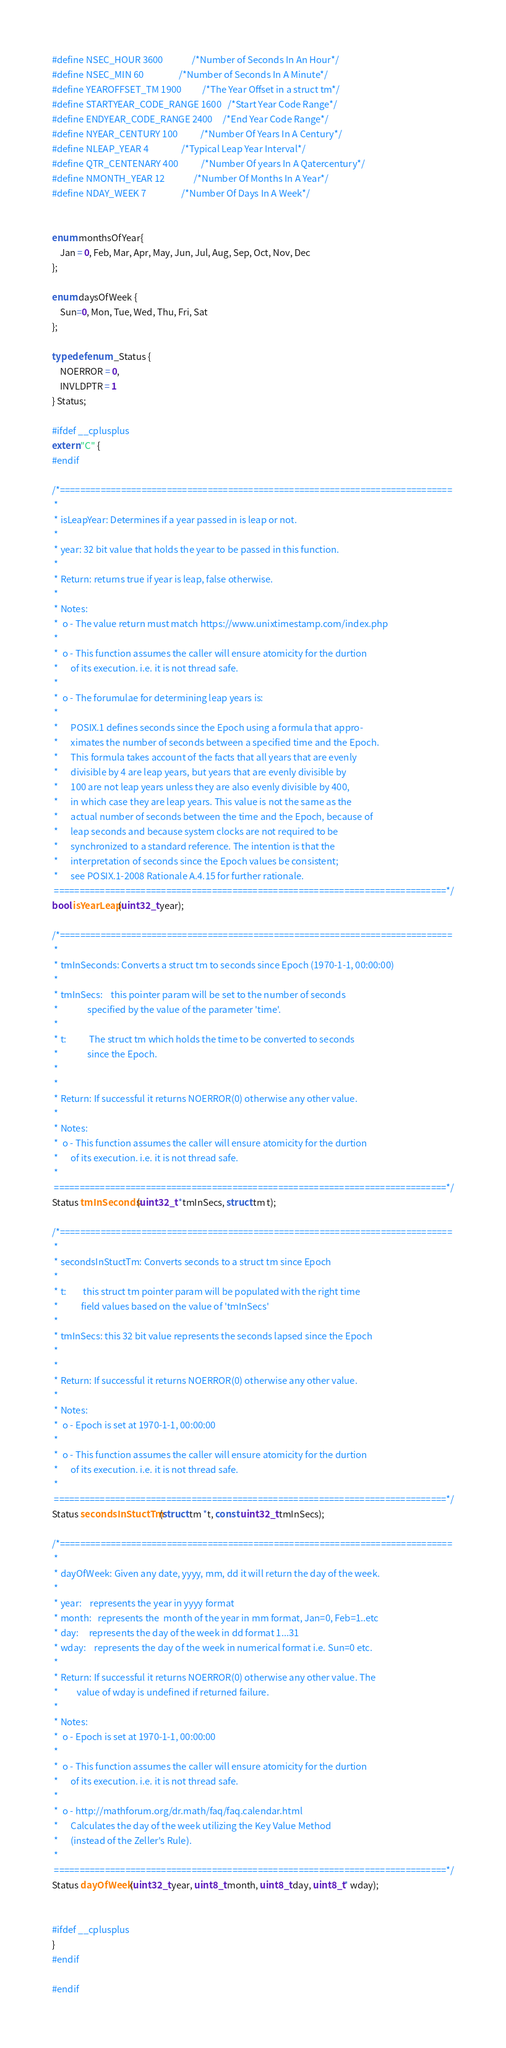<code> <loc_0><loc_0><loc_500><loc_500><_C_>#define NSEC_HOUR 3600              /*Number of Seconds In An Hour*/
#define NSEC_MIN 60                 /*Number of Seconds In A Minute*/
#define YEAROFFSET_TM 1900          /*The Year Offset in a struct tm*/
#define STARTYEAR_CODE_RANGE 1600   /*Start Year Code Range*/
#define ENDYEAR_CODE_RANGE 2400     /*End Year Code Range*/
#define NYEAR_CENTURY 100           /*Number Of Years In A Century*/
#define NLEAP_YEAR 4                /*Typical Leap Year Interval*/
#define QTR_CENTENARY 400           /*Number Of years In A Qatercentury*/
#define NMONTH_YEAR 12              /*Number Of Months In A Year*/
#define NDAY_WEEK 7                 /*Number Of Days In A Week*/


enum monthsOfYear{
    Jan = 0, Feb, Mar, Apr, May, Jun, Jul, Aug, Sep, Oct, Nov, Dec
};

enum daysOfWeek {
    Sun=0, Mon, Tue, Wed, Thu, Fri, Sat
};

typedef enum _Status {
    NOERROR = 0,
    INVLDPTR = 1
} Status;

#ifdef __cplusplus
extern "C" {
#endif

/*=============================================================================
 *
 * isLeapYear: Determines if a year passed in is leap or not.
 *
 * year: 32 bit value that holds the year to be passed in this function.
 *
 * Return: returns true if year is leap, false otherwise.
 *
 * Notes:
 *  o - The value return must match https://www.unixtimestamp.com/index.php
 *
 *  o - This function assumes the caller will ensure atomicity for the durtion
 *      of its execution. i.e. it is not thread safe.
 *
 *  o - The forumulae for determining leap years is:
 *
 *      POSIX.1 defines seconds since the Epoch using a formula that appro-
 *      ximates the number of seconds between a specified time and the Epoch.
 *      This formula takes account of the facts that all years that are evenly
 *      divisible by 4 are leap years, but years that are evenly divisible by
 *      100 are not leap years unless they are also evenly divisible by 400,
 *      in which case they are leap years. This value is not the same as the
 *      actual number of seconds between the time and the Epoch, because of
 *      leap seconds and because system clocks are not required to be
 *      synchronized to a standard reference. The intention is that the
 *      interpretation of seconds since the Epoch values be consistent;
 *      see POSIX.1-2008 Rationale A.4.15 for further rationale.
 =============================================================================*/
bool isYearLeap(uint32_t year);

/*=============================================================================
 *
 * tmInSeconds: Converts a struct tm to seconds since Epoch (1970-1-1, 00:00:00)
 *
 * tmInSecs:    this pointer param will be set to the number of seconds
 *              specified by the value of the parameter 'time'.
 *
 * t:           The struct tm which holds the time to be converted to seconds
 *              since the Epoch.
 *
 *
 * Return: If successful it returns NOERROR(0) otherwise any other value.
 *
 * Notes:
 *  o - This function assumes the caller will ensure atomicity for the durtion
 *      of its execution. i.e. it is not thread safe.
 *
 =============================================================================*/
Status tmInSeconds(uint32_t *tmInSecs, struct tm t);

/*=============================================================================
 *
 * secondsInStuctTm: Converts seconds to a struct tm since Epoch
 *
 * t:        this struct tm pointer param will be populated with the right time
 *           field values based on the value of 'tmInSecs'
 *
 * tmInSecs: this 32 bit value represents the seconds lapsed since the Epoch
 *
 *
 * Return: If successful it returns NOERROR(0) otherwise any other value.
 *
 * Notes:
 *  o - Epoch is set at 1970-1-1, 00:00:00
 *
 *  o - This function assumes the caller will ensure atomicity for the durtion
 *      of its execution. i.e. it is not thread safe.
 *
 =============================================================================*/
Status secondsInStuctTm(struct tm *t, const uint32_t tmInSecs);

/*=============================================================================
 *
 * dayOfWeek: Given any date, yyyy, mm, dd it will return the day of the week.
 *
 * year:    represents the year in yyyy format
 * month:   represents the  month of the year in mm format, Jan=0, Feb=1..etc
 * day:     represents the day of the week in dd format 1...31
 * wday:    represents the day of the week in numerical format i.e. Sun=0 etc.
 *
 * Return: If successful it returns NOERROR(0) otherwise any other value. The
 *         value of wday is undefined if returned failure.
 *
 * Notes:
 *  o - Epoch is set at 1970-1-1, 00:00:00
 *
 *  o - This function assumes the caller will ensure atomicity for the durtion
 *      of its execution. i.e. it is not thread safe.
 *
 *  o - http://mathforum.org/dr.math/faq/faq.calendar.html
 *      Calculates the day of the week utilizing the Key Value Method
 *      (instead of the Zeller's Rule).
 *
 =============================================================================*/
Status dayOfWeek(uint32_t year, uint8_t month, uint8_t day, uint8_t* wday);


#ifdef __cplusplus
}
#endif

#endif
</code> 